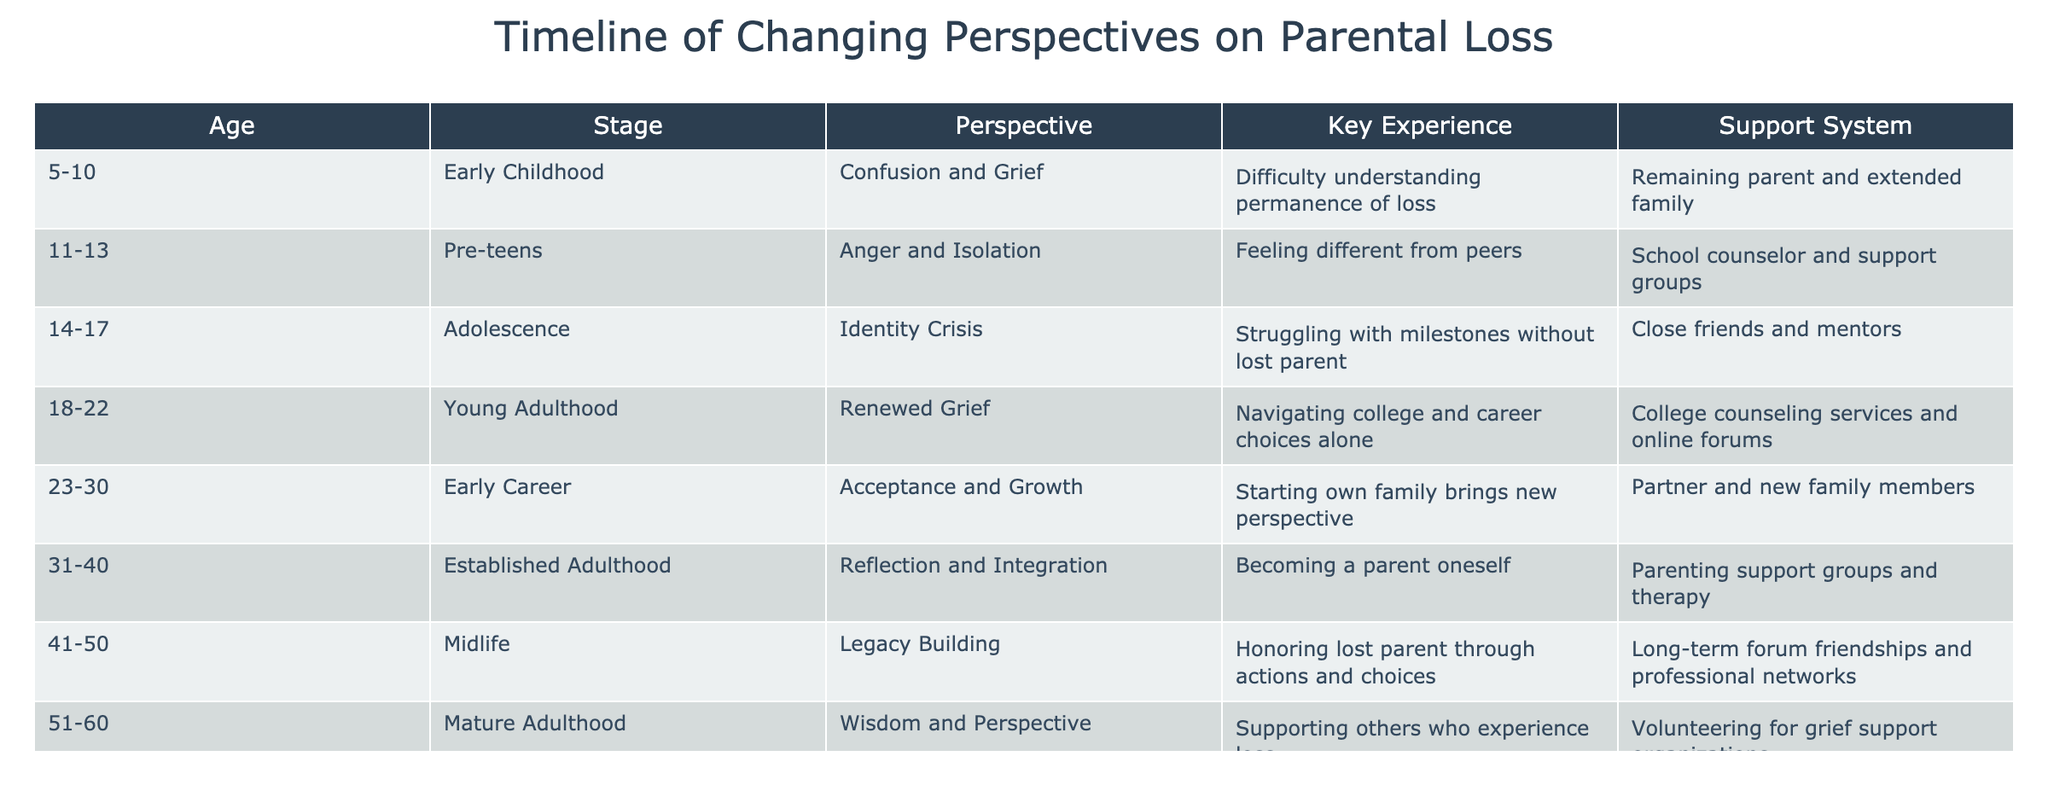What perspective do individuals have during Early Childhood? According to the table, during the Early Childhood stage (ages 5-10), the perspective on parental loss is described as confusion and grief.
Answer: Confusion and grief What support system is mentioned for individuals in Young Adulthood? The table shows that in the Young Adulthood stage (ages 18-22), the support system includes college counseling services and online forums.
Answer: College counseling services and online forums How many distinct perspectives on parental loss are listed in the table? By counting the number of unique entries in the Perspective column, which consists of eight separate perspectives, it can be concluded that there are eight distinct perspectives listed.
Answer: Eight Is the experience in Established Adulthood characterized by reflection? The table indicates that during Established Adulthood (ages 31-40), individuals experience reflection and integration, so this statement is true.
Answer: Yes What can be inferred about the change in perspective from Early Childhood to Midlife? From Early Childhood to Midlife, the perspectives evolve from confusion and grief to legacy building, indicating a significant development in coping mechanisms and understanding of the loss over time. This demonstrates a transition from a focus on immediate emotional responses to a broader reflection on legacy and impact.
Answer: Yes, the perspective evolves significantly 